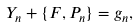<formula> <loc_0><loc_0><loc_500><loc_500>Y _ { n } + \{ F , P _ { n } \} = g _ { n } ,</formula> 